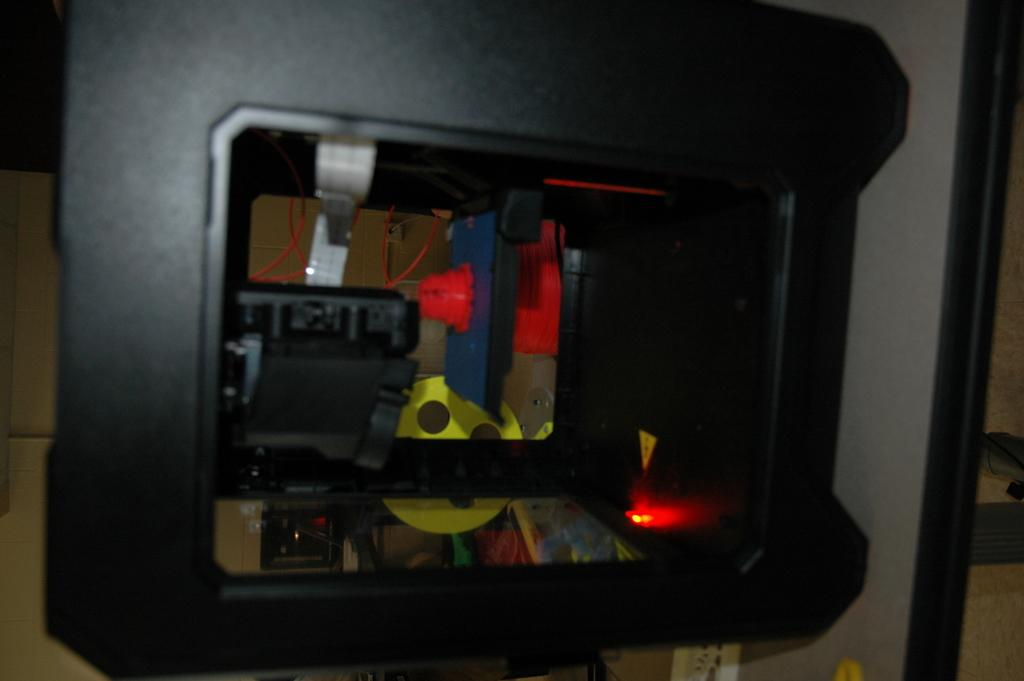What is the main subject in the center of the image? There is a black object in the center of the image. Can you describe the appearance of the object? The object has light inside it. Are there any additional features associated with the object? Yes, there are wires associated with the object. What type of gold loaf is being held by the grandmother in the image? There is no grandmother or gold loaf present in the image. 